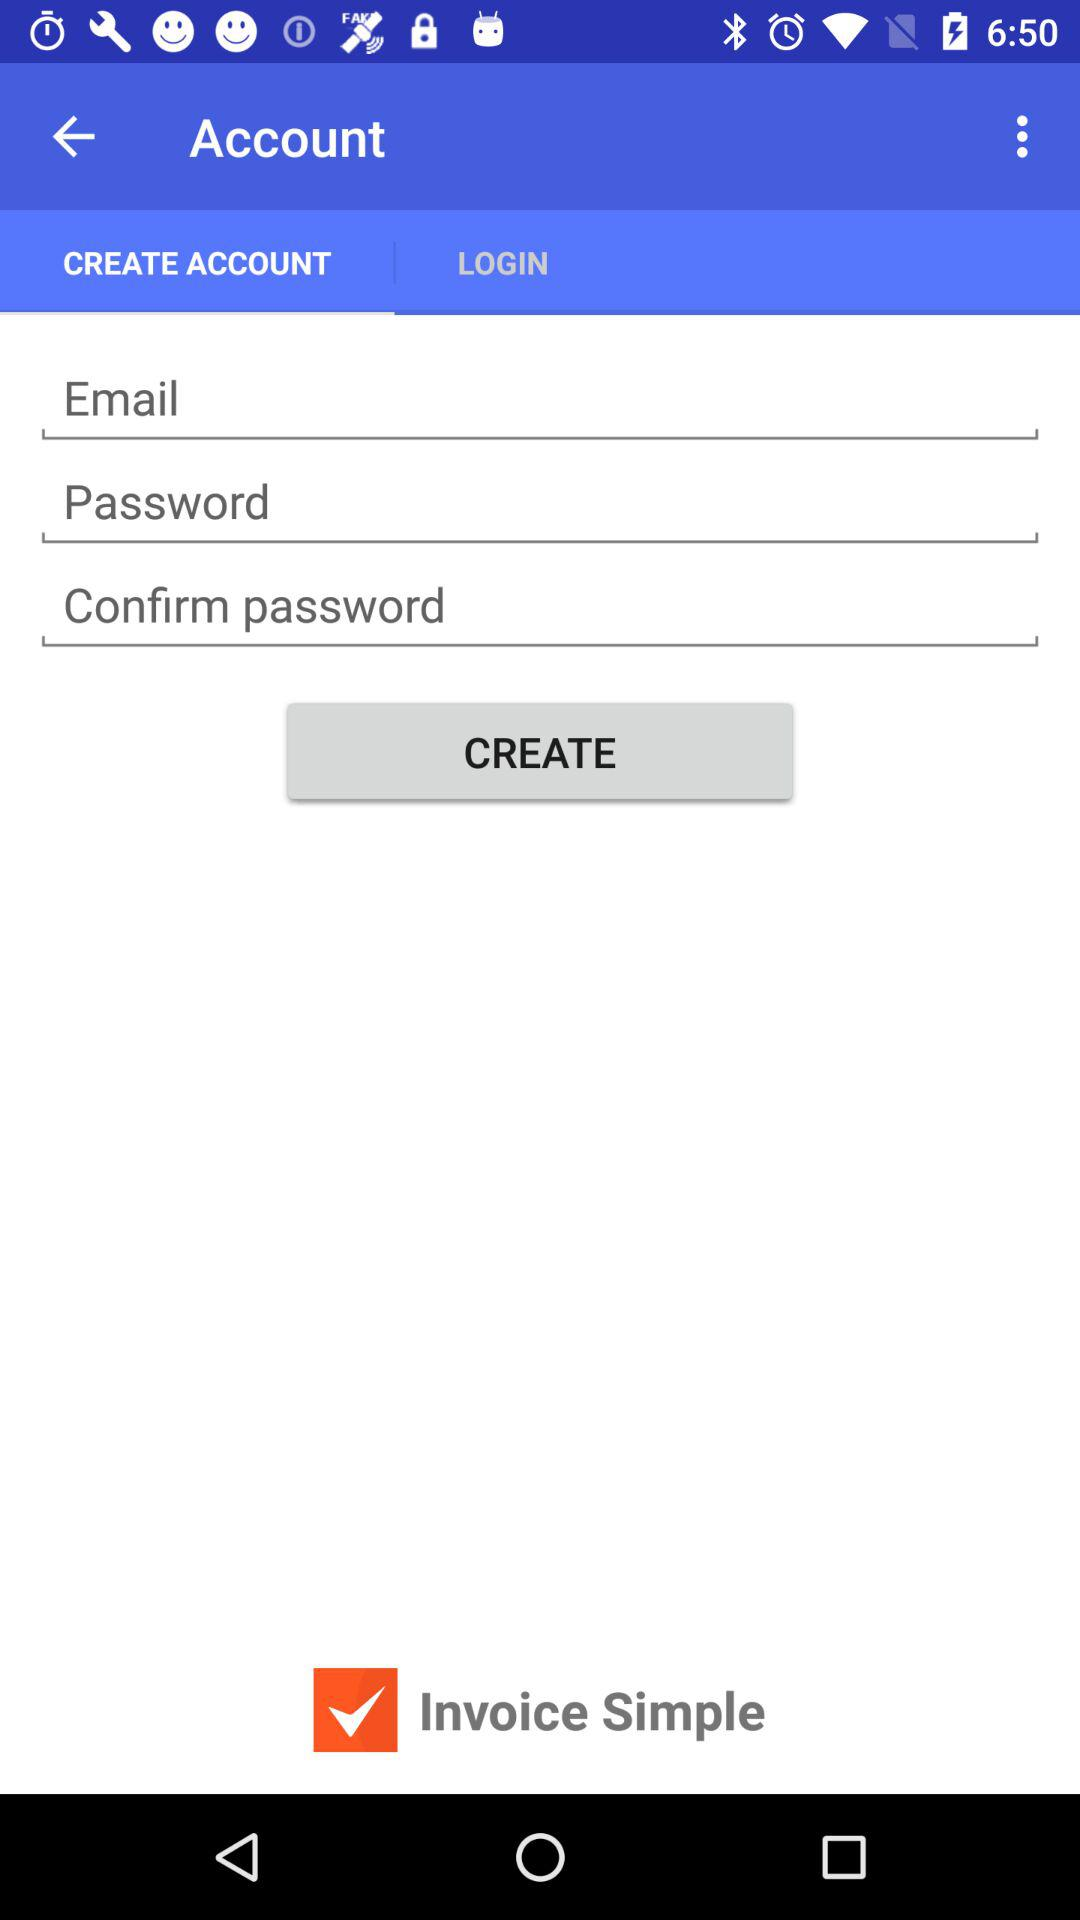What is the username?
When the provided information is insufficient, respond with <no answer>. <no answer> 